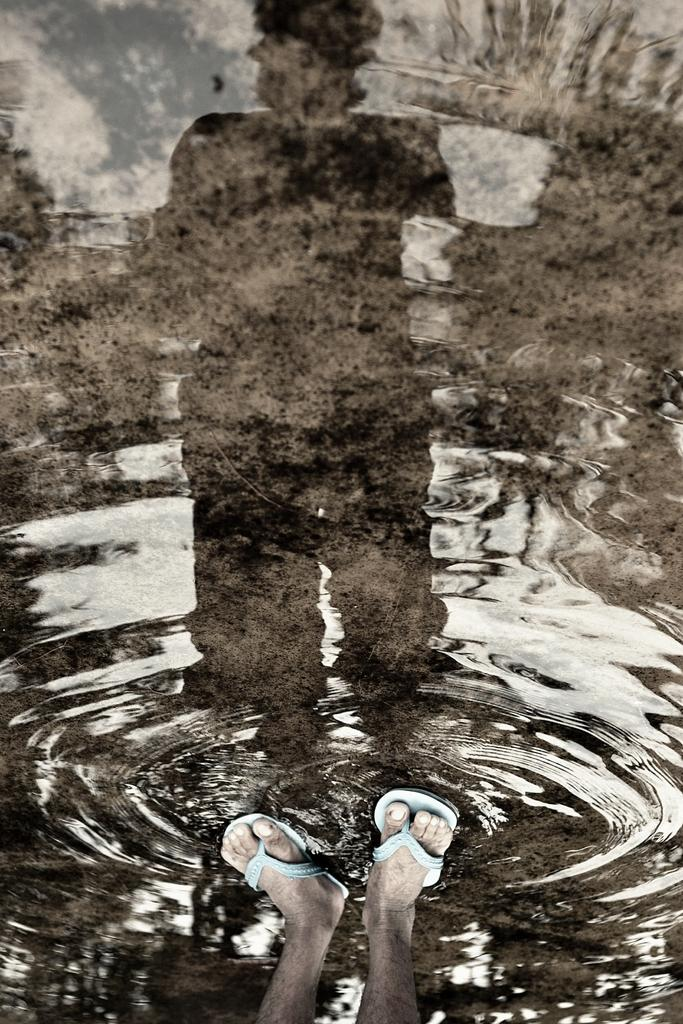What is visible in the image? Water is visible in the image. Can you describe any other elements in the image? There are legs of a person in the image, and the reflection of a person is visible in the water. What type of clover can be seen growing near the water's edge in the image? There is no clover visible in the image; it only features water, legs of a person, and the reflection of a person. 